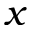<formula> <loc_0><loc_0><loc_500><loc_500>x</formula> 